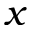<formula> <loc_0><loc_0><loc_500><loc_500>x</formula> 